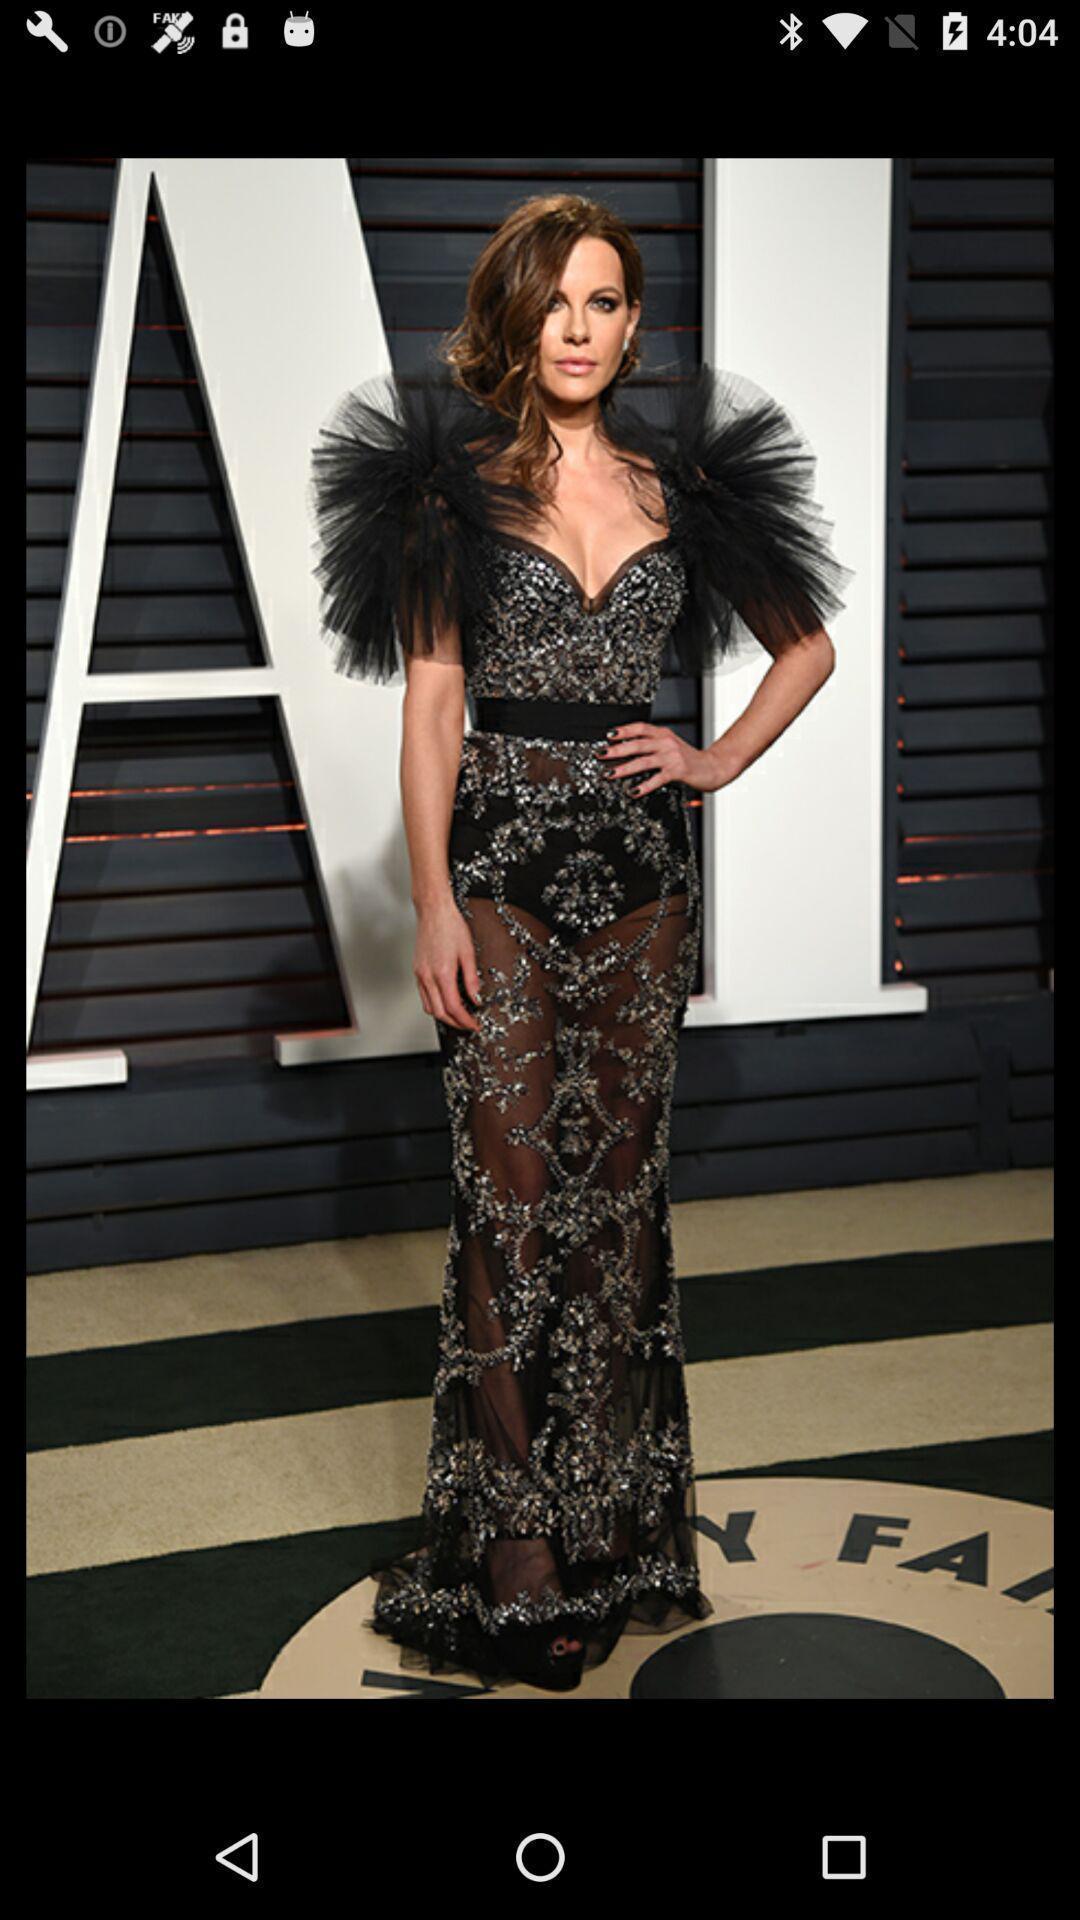What can you discern from this picture? Screen showing an image. 